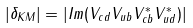Convert formula to latex. <formula><loc_0><loc_0><loc_500><loc_500>| \delta _ { K M } | = | I m ( V _ { c d } V _ { u b } V _ { c b } ^ { \ast } V _ { u d } ^ { \ast } ) |</formula> 